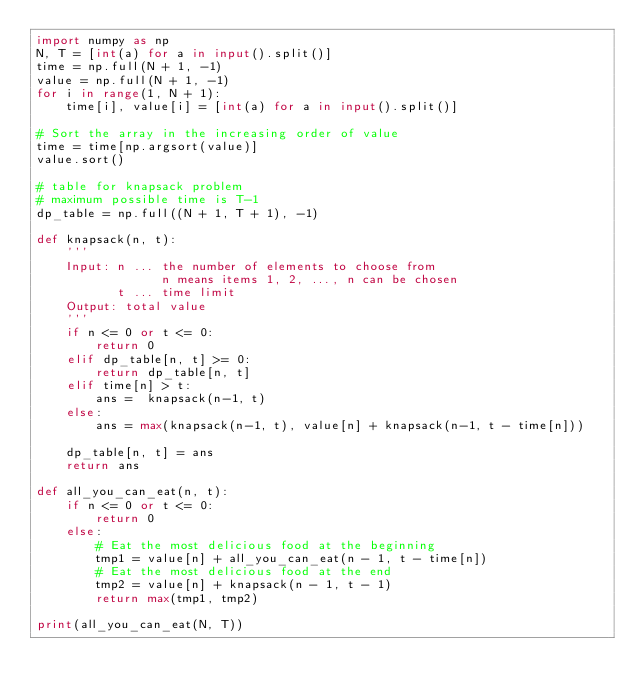<code> <loc_0><loc_0><loc_500><loc_500><_Python_>import numpy as np
N, T = [int(a) for a in input().split()]
time = np.full(N + 1, -1)
value = np.full(N + 1, -1)
for i in range(1, N + 1):
    time[i], value[i] = [int(a) for a in input().split()]

# Sort the array in the increasing order of value
time = time[np.argsort(value)]
value.sort()

# table for knapsack problem
# maximum possible time is T-1
dp_table = np.full((N + 1, T + 1), -1)

def knapsack(n, t):
    '''
    Input: n ... the number of elements to choose from
                 n means items 1, 2, ..., n can be chosen
           t ... time limit
    Output: total value
    '''
    if n <= 0 or t <= 0:
        return 0
    elif dp_table[n, t] >= 0:
        return dp_table[n, t]
    elif time[n] > t:
        ans =  knapsack(n-1, t)
    else:
        ans = max(knapsack(n-1, t), value[n] + knapsack(n-1, t - time[n]))

    dp_table[n, t] = ans
    return ans

def all_you_can_eat(n, t):
    if n <= 0 or t <= 0:
        return 0
    else:
        # Eat the most delicious food at the beginning
        tmp1 = value[n] + all_you_can_eat(n - 1, t - time[n])
        # Eat the most delicious food at the end
        tmp2 = value[n] + knapsack(n - 1, t - 1)
        return max(tmp1, tmp2)

print(all_you_can_eat(N, T))
</code> 